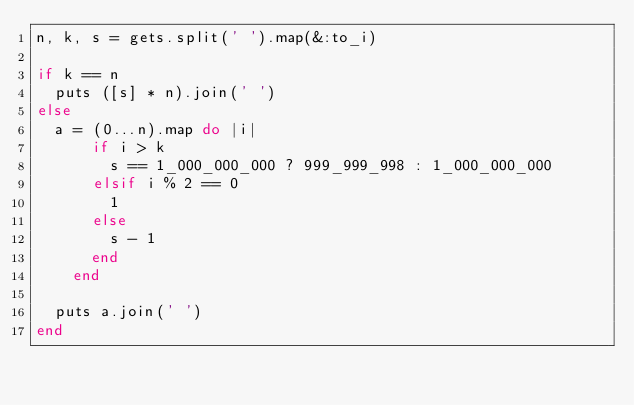<code> <loc_0><loc_0><loc_500><loc_500><_Ruby_>n, k, s = gets.split(' ').map(&:to_i)

if k == n
  puts ([s] * n).join(' ')
else
  a = (0...n).map do |i|
      if i > k
        s == 1_000_000_000 ? 999_999_998 : 1_000_000_000
      elsif i % 2 == 0
        1
      else
        s - 1
      end
    end

  puts a.join(' ')
end</code> 